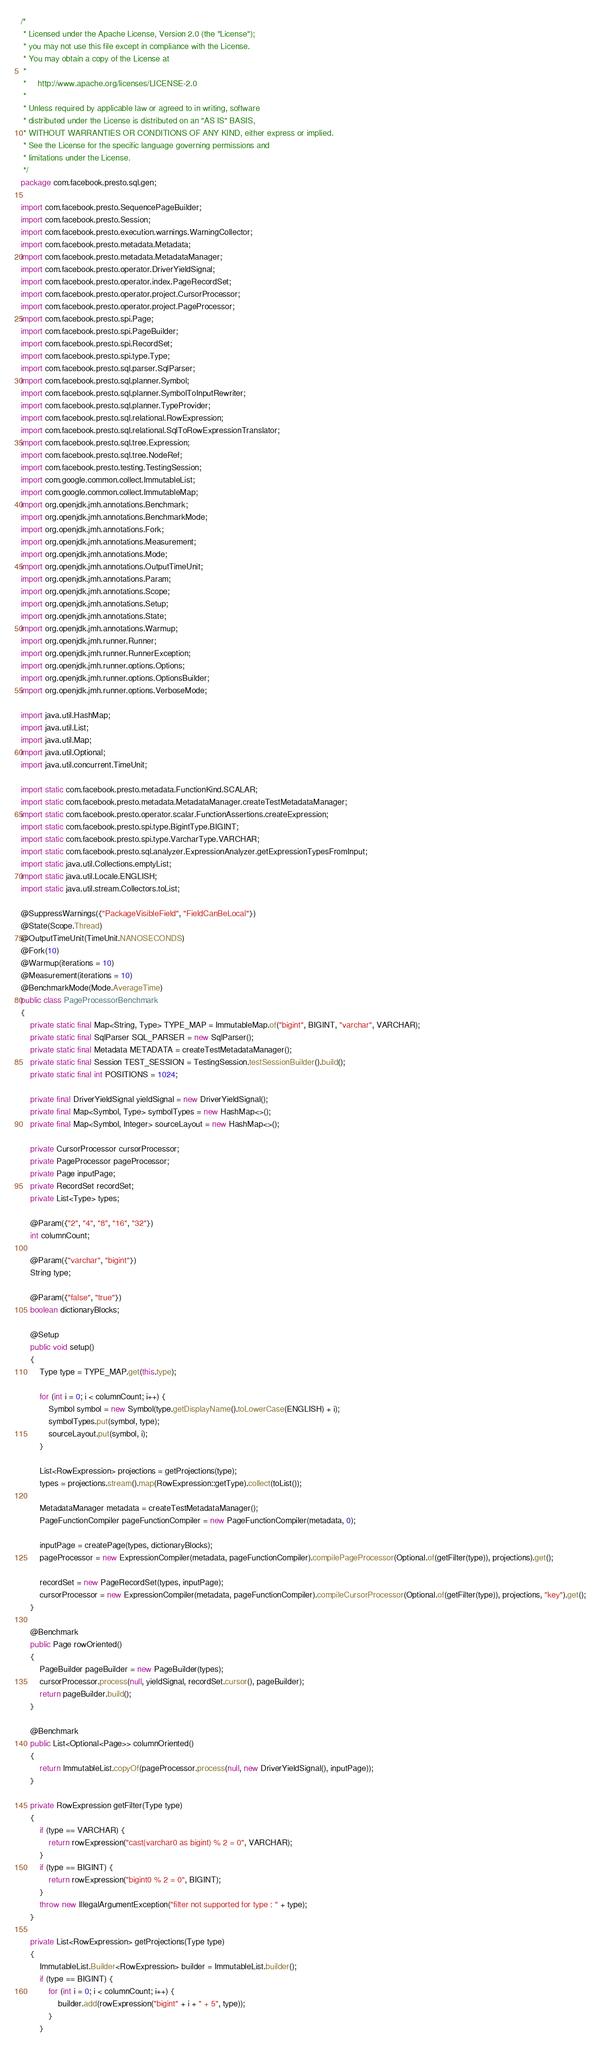Convert code to text. <code><loc_0><loc_0><loc_500><loc_500><_Java_>/*
 * Licensed under the Apache License, Version 2.0 (the "License");
 * you may not use this file except in compliance with the License.
 * You may obtain a copy of the License at
 *
 *     http://www.apache.org/licenses/LICENSE-2.0
 *
 * Unless required by applicable law or agreed to in writing, software
 * distributed under the License is distributed on an "AS IS" BASIS,
 * WITHOUT WARRANTIES OR CONDITIONS OF ANY KIND, either express or implied.
 * See the License for the specific language governing permissions and
 * limitations under the License.
 */
package com.facebook.presto.sql.gen;

import com.facebook.presto.SequencePageBuilder;
import com.facebook.presto.Session;
import com.facebook.presto.execution.warnings.WarningCollector;
import com.facebook.presto.metadata.Metadata;
import com.facebook.presto.metadata.MetadataManager;
import com.facebook.presto.operator.DriverYieldSignal;
import com.facebook.presto.operator.index.PageRecordSet;
import com.facebook.presto.operator.project.CursorProcessor;
import com.facebook.presto.operator.project.PageProcessor;
import com.facebook.presto.spi.Page;
import com.facebook.presto.spi.PageBuilder;
import com.facebook.presto.spi.RecordSet;
import com.facebook.presto.spi.type.Type;
import com.facebook.presto.sql.parser.SqlParser;
import com.facebook.presto.sql.planner.Symbol;
import com.facebook.presto.sql.planner.SymbolToInputRewriter;
import com.facebook.presto.sql.planner.TypeProvider;
import com.facebook.presto.sql.relational.RowExpression;
import com.facebook.presto.sql.relational.SqlToRowExpressionTranslator;
import com.facebook.presto.sql.tree.Expression;
import com.facebook.presto.sql.tree.NodeRef;
import com.facebook.presto.testing.TestingSession;
import com.google.common.collect.ImmutableList;
import com.google.common.collect.ImmutableMap;
import org.openjdk.jmh.annotations.Benchmark;
import org.openjdk.jmh.annotations.BenchmarkMode;
import org.openjdk.jmh.annotations.Fork;
import org.openjdk.jmh.annotations.Measurement;
import org.openjdk.jmh.annotations.Mode;
import org.openjdk.jmh.annotations.OutputTimeUnit;
import org.openjdk.jmh.annotations.Param;
import org.openjdk.jmh.annotations.Scope;
import org.openjdk.jmh.annotations.Setup;
import org.openjdk.jmh.annotations.State;
import org.openjdk.jmh.annotations.Warmup;
import org.openjdk.jmh.runner.Runner;
import org.openjdk.jmh.runner.RunnerException;
import org.openjdk.jmh.runner.options.Options;
import org.openjdk.jmh.runner.options.OptionsBuilder;
import org.openjdk.jmh.runner.options.VerboseMode;

import java.util.HashMap;
import java.util.List;
import java.util.Map;
import java.util.Optional;
import java.util.concurrent.TimeUnit;

import static com.facebook.presto.metadata.FunctionKind.SCALAR;
import static com.facebook.presto.metadata.MetadataManager.createTestMetadataManager;
import static com.facebook.presto.operator.scalar.FunctionAssertions.createExpression;
import static com.facebook.presto.spi.type.BigintType.BIGINT;
import static com.facebook.presto.spi.type.VarcharType.VARCHAR;
import static com.facebook.presto.sql.analyzer.ExpressionAnalyzer.getExpressionTypesFromInput;
import static java.util.Collections.emptyList;
import static java.util.Locale.ENGLISH;
import static java.util.stream.Collectors.toList;

@SuppressWarnings({"PackageVisibleField", "FieldCanBeLocal"})
@State(Scope.Thread)
@OutputTimeUnit(TimeUnit.NANOSECONDS)
@Fork(10)
@Warmup(iterations = 10)
@Measurement(iterations = 10)
@BenchmarkMode(Mode.AverageTime)
public class PageProcessorBenchmark
{
    private static final Map<String, Type> TYPE_MAP = ImmutableMap.of("bigint", BIGINT, "varchar", VARCHAR);
    private static final SqlParser SQL_PARSER = new SqlParser();
    private static final Metadata METADATA = createTestMetadataManager();
    private static final Session TEST_SESSION = TestingSession.testSessionBuilder().build();
    private static final int POSITIONS = 1024;

    private final DriverYieldSignal yieldSignal = new DriverYieldSignal();
    private final Map<Symbol, Type> symbolTypes = new HashMap<>();
    private final Map<Symbol, Integer> sourceLayout = new HashMap<>();

    private CursorProcessor cursorProcessor;
    private PageProcessor pageProcessor;
    private Page inputPage;
    private RecordSet recordSet;
    private List<Type> types;

    @Param({"2", "4", "8", "16", "32"})
    int columnCount;

    @Param({"varchar", "bigint"})
    String type;

    @Param({"false", "true"})
    boolean dictionaryBlocks;

    @Setup
    public void setup()
    {
        Type type = TYPE_MAP.get(this.type);

        for (int i = 0; i < columnCount; i++) {
            Symbol symbol = new Symbol(type.getDisplayName().toLowerCase(ENGLISH) + i);
            symbolTypes.put(symbol, type);
            sourceLayout.put(symbol, i);
        }

        List<RowExpression> projections = getProjections(type);
        types = projections.stream().map(RowExpression::getType).collect(toList());

        MetadataManager metadata = createTestMetadataManager();
        PageFunctionCompiler pageFunctionCompiler = new PageFunctionCompiler(metadata, 0);

        inputPage = createPage(types, dictionaryBlocks);
        pageProcessor = new ExpressionCompiler(metadata, pageFunctionCompiler).compilePageProcessor(Optional.of(getFilter(type)), projections).get();

        recordSet = new PageRecordSet(types, inputPage);
        cursorProcessor = new ExpressionCompiler(metadata, pageFunctionCompiler).compileCursorProcessor(Optional.of(getFilter(type)), projections, "key").get();
    }

    @Benchmark
    public Page rowOriented()
    {
        PageBuilder pageBuilder = new PageBuilder(types);
        cursorProcessor.process(null, yieldSignal, recordSet.cursor(), pageBuilder);
        return pageBuilder.build();
    }

    @Benchmark
    public List<Optional<Page>> columnOriented()
    {
        return ImmutableList.copyOf(pageProcessor.process(null, new DriverYieldSignal(), inputPage));
    }

    private RowExpression getFilter(Type type)
    {
        if (type == VARCHAR) {
            return rowExpression("cast(varchar0 as bigint) % 2 = 0", VARCHAR);
        }
        if (type == BIGINT) {
            return rowExpression("bigint0 % 2 = 0", BIGINT);
        }
        throw new IllegalArgumentException("filter not supported for type : " + type);
    }

    private List<RowExpression> getProjections(Type type)
    {
        ImmutableList.Builder<RowExpression> builder = ImmutableList.builder();
        if (type == BIGINT) {
            for (int i = 0; i < columnCount; i++) {
                builder.add(rowExpression("bigint" + i + " + 5", type));
            }
        }</code> 